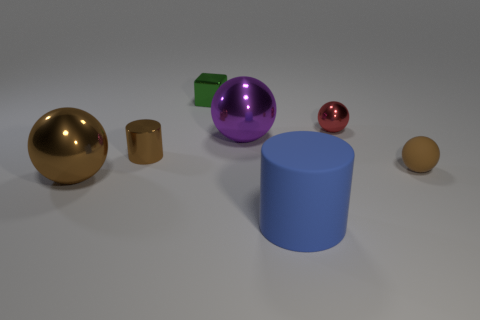Subtract all yellow spheres. Subtract all brown blocks. How many spheres are left? 4 Add 1 gray metal objects. How many objects exist? 8 Subtract all balls. How many objects are left? 3 Add 3 brown balls. How many brown balls exist? 5 Subtract 0 yellow cubes. How many objects are left? 7 Subtract all tiny green rubber blocks. Subtract all large rubber cylinders. How many objects are left? 6 Add 2 big brown balls. How many big brown balls are left? 3 